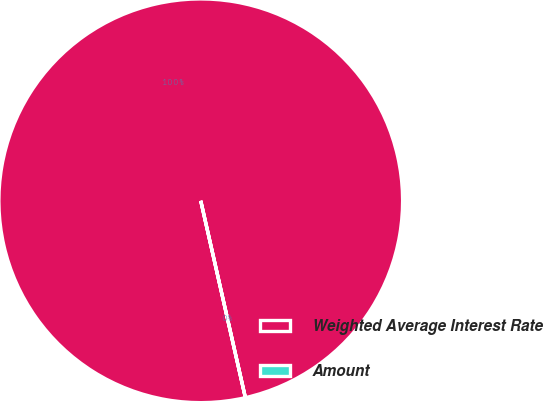<chart> <loc_0><loc_0><loc_500><loc_500><pie_chart><fcel>Weighted Average Interest Rate<fcel>Amount<nl><fcel>100.0%<fcel>0.0%<nl></chart> 